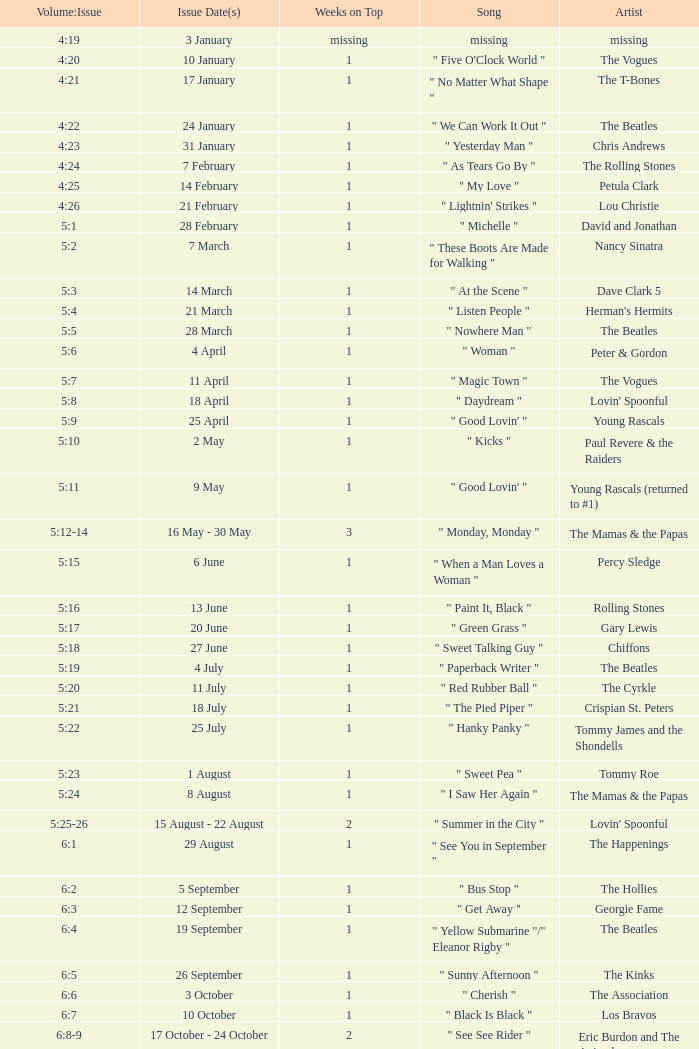Which beatles artist has a record dated 19 september and how many weeks is it listed as being on top? 1.0. Would you mind parsing the complete table? {'header': ['Volume:Issue', 'Issue Date(s)', 'Weeks on Top', 'Song', 'Artist'], 'rows': [['4:19', '3 January', 'missing', 'missing', 'missing'], ['4:20', '10 January', '1', '" Five O\'Clock World "', 'The Vogues'], ['4:21', '17 January', '1', '" No Matter What Shape "', 'The T-Bones'], ['4:22', '24 January', '1', '" We Can Work It Out "', 'The Beatles'], ['4:23', '31 January', '1', '" Yesterday Man "', 'Chris Andrews'], ['4:24', '7 February', '1', '" As Tears Go By "', 'The Rolling Stones'], ['4:25', '14 February', '1', '" My Love "', 'Petula Clark'], ['4:26', '21 February', '1', '" Lightnin\' Strikes "', 'Lou Christie'], ['5:1', '28 February', '1', '" Michelle "', 'David and Jonathan'], ['5:2', '7 March', '1', '" These Boots Are Made for Walking "', 'Nancy Sinatra'], ['5:3', '14 March', '1', '" At the Scene "', 'Dave Clark 5'], ['5:4', '21 March', '1', '" Listen People "', "Herman's Hermits"], ['5:5', '28 March', '1', '" Nowhere Man "', 'The Beatles'], ['5:6', '4 April', '1', '" Woman "', 'Peter & Gordon'], ['5:7', '11 April', '1', '" Magic Town "', 'The Vogues'], ['5:8', '18 April', '1', '" Daydream "', "Lovin' Spoonful"], ['5:9', '25 April', '1', '" Good Lovin\' "', 'Young Rascals'], ['5:10', '2 May', '1', '" Kicks "', 'Paul Revere & the Raiders'], ['5:11', '9 May', '1', '" Good Lovin\' "', 'Young Rascals (returned to #1)'], ['5:12-14', '16 May - 30 May', '3', '" Monday, Monday "', 'The Mamas & the Papas'], ['5:15', '6 June', '1', '" When a Man Loves a Woman "', 'Percy Sledge'], ['5:16', '13 June', '1', '" Paint It, Black "', 'Rolling Stones'], ['5:17', '20 June', '1', '" Green Grass "', 'Gary Lewis'], ['5:18', '27 June', '1', '" Sweet Talking Guy "', 'Chiffons'], ['5:19', '4 July', '1', '" Paperback Writer "', 'The Beatles'], ['5:20', '11 July', '1', '" Red Rubber Ball "', 'The Cyrkle'], ['5:21', '18 July', '1', '" The Pied Piper "', 'Crispian St. Peters'], ['5:22', '25 July', '1', '" Hanky Panky "', 'Tommy James and the Shondells'], ['5:23', '1 August', '1', '" Sweet Pea "', 'Tommy Roe'], ['5:24', '8 August', '1', '" I Saw Her Again "', 'The Mamas & the Papas'], ['5:25-26', '15 August - 22 August', '2', '" Summer in the City "', "Lovin' Spoonful"], ['6:1', '29 August', '1', '" See You in September "', 'The Happenings'], ['6:2', '5 September', '1', '" Bus Stop "', 'The Hollies'], ['6:3', '12 September', '1', '" Get Away "', 'Georgie Fame'], ['6:4', '19 September', '1', '" Yellow Submarine "/" Eleanor Rigby "', 'The Beatles'], ['6:5', '26 September', '1', '" Sunny Afternoon "', 'The Kinks'], ['6:6', '3 October', '1', '" Cherish "', 'The Association'], ['6:7', '10 October', '1', '" Black Is Black "', 'Los Bravos'], ['6:8-9', '17 October - 24 October', '2', '" See See Rider "', 'Eric Burdon and The Animals'], ['6:10', '31 October', '1', '" 96 Tears "', 'Question Mark & the Mysterians'], ['6:11', '7 November', '1', '" Last Train to Clarksville "', 'The Monkees'], ['6:12', '14 November', '1', '" Dandy "', "Herman's Hermits"], ['6:13', '21 November', '1', '" Poor Side of Town "', 'Johnny Rivers'], ['6:14-15', '28 November - 5 December', '2', '" Winchester Cathedral "', 'New Vaudeville Band'], ['6:16', '12 December', '1', '" Lady Godiva "', 'Peter & Gordon'], ['6:17', '19 December', '1', '" Stop! Stop! Stop! "', 'The Hollies'], ['6:18-19', '26 December - 2 January', '2', '" I\'m a Believer "', 'The Monkees']]} 